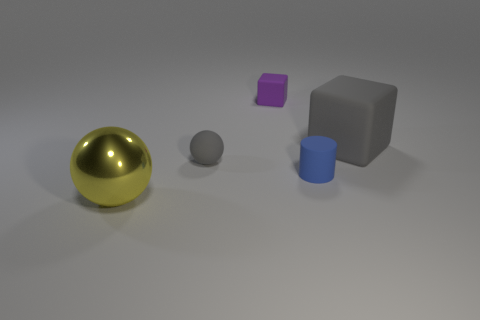Subtract all gray cylinders. Subtract all cyan balls. How many cylinders are left? 1 Add 1 big metallic cylinders. How many objects exist? 6 Subtract all spheres. How many objects are left? 3 Subtract all cyan shiny cubes. Subtract all tiny matte things. How many objects are left? 2 Add 5 tiny gray rubber objects. How many tiny gray rubber objects are left? 6 Add 3 large brown matte cubes. How many large brown matte cubes exist? 3 Subtract 1 gray spheres. How many objects are left? 4 